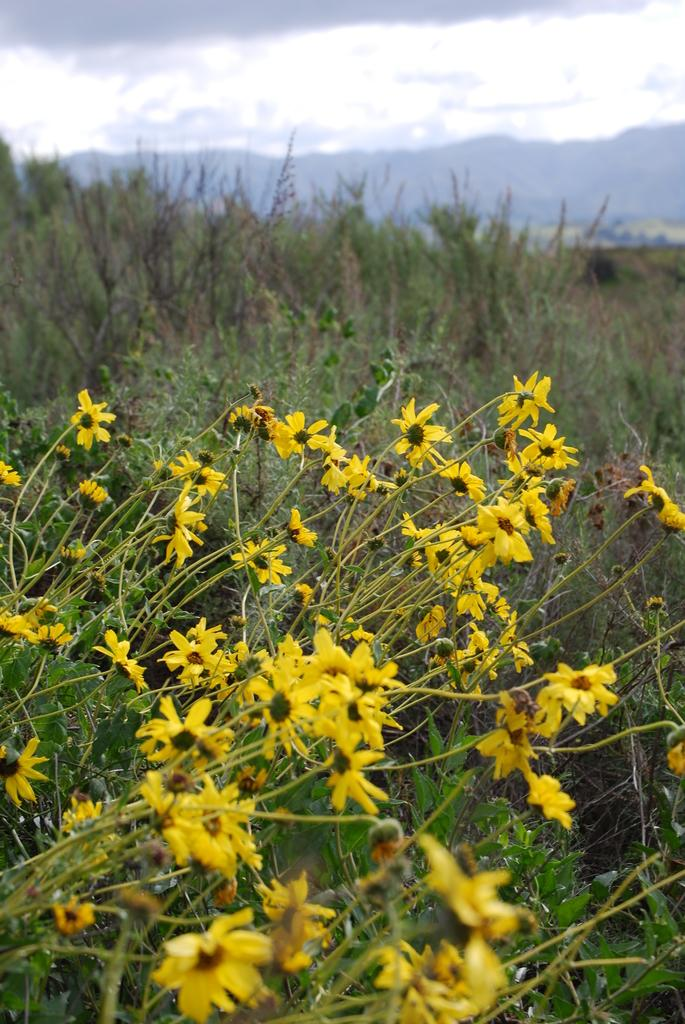What type of vegetation can be seen in the image? There are flowers, plants, and trees in the image. What type of landscape feature is present in the image? There are hills in the image. What part of the natural environment is visible in the image? The sky is visible in the image. What type of rail can be seen in the image? There is no rail present in the image. Is there a turkey visible in the image? No, there is no turkey present in the image. 